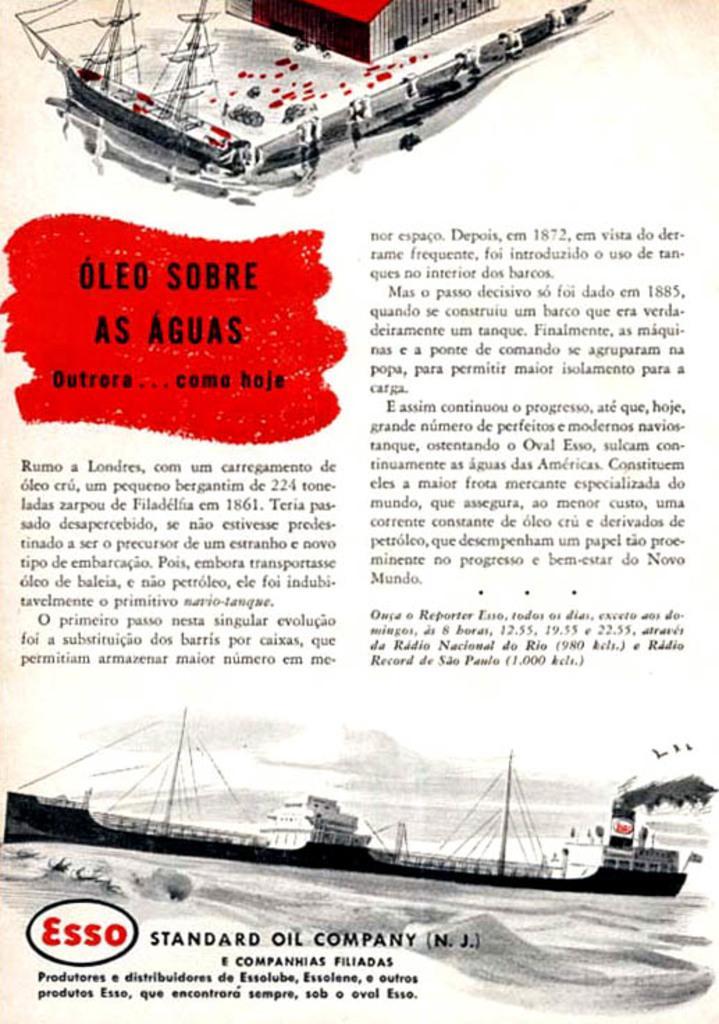Please provide a concise description of this image. In this image we can see the poster. On the poster at the top we can see some boats, house. At the bottom of the poster we can see boats, logo. In the middle of the poster we can see some words. 